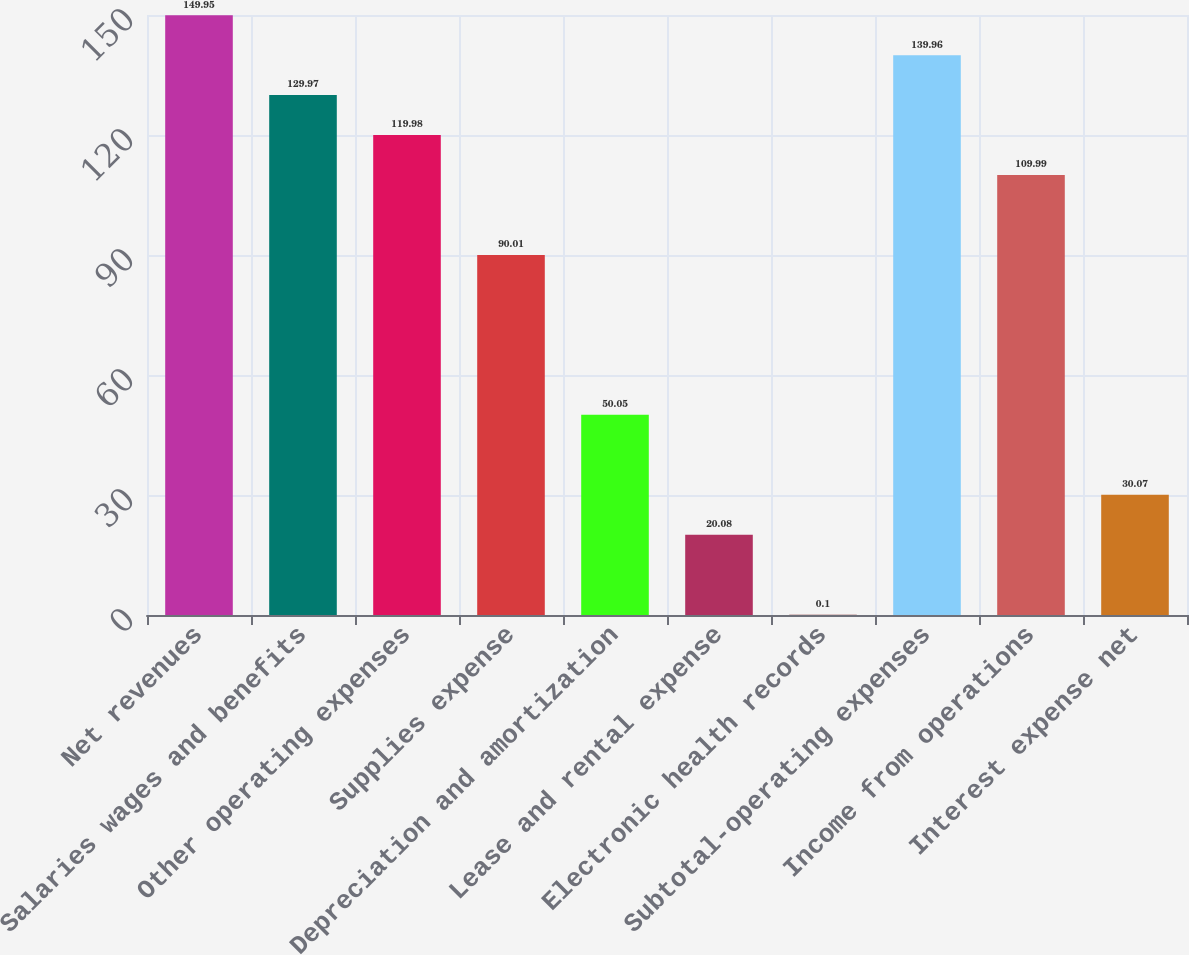Convert chart. <chart><loc_0><loc_0><loc_500><loc_500><bar_chart><fcel>Net revenues<fcel>Salaries wages and benefits<fcel>Other operating expenses<fcel>Supplies expense<fcel>Depreciation and amortization<fcel>Lease and rental expense<fcel>Electronic health records<fcel>Subtotal-operating expenses<fcel>Income from operations<fcel>Interest expense net<nl><fcel>149.95<fcel>129.97<fcel>119.98<fcel>90.01<fcel>50.05<fcel>20.08<fcel>0.1<fcel>139.96<fcel>109.99<fcel>30.07<nl></chart> 